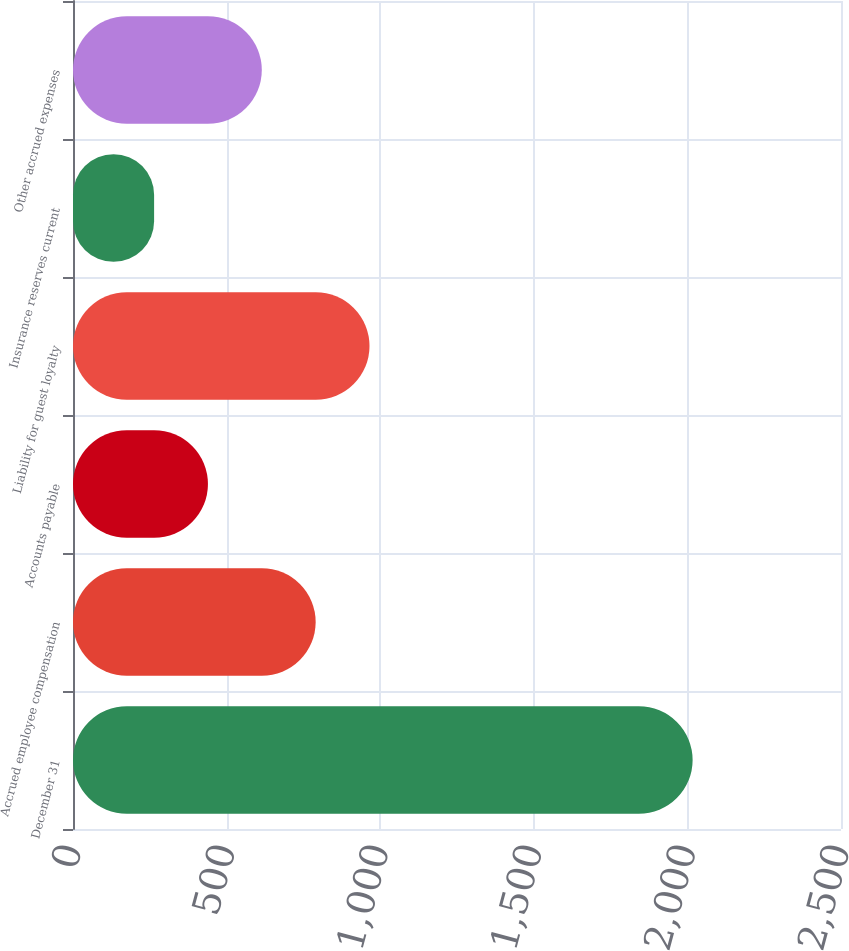Convert chart. <chart><loc_0><loc_0><loc_500><loc_500><bar_chart><fcel>December 31<fcel>Accrued employee compensation<fcel>Accounts payable<fcel>Liability for guest loyalty<fcel>Insurance reserves current<fcel>Other accrued expenses<nl><fcel>2017<fcel>789.9<fcel>439.3<fcel>965.2<fcel>264<fcel>614.6<nl></chart> 